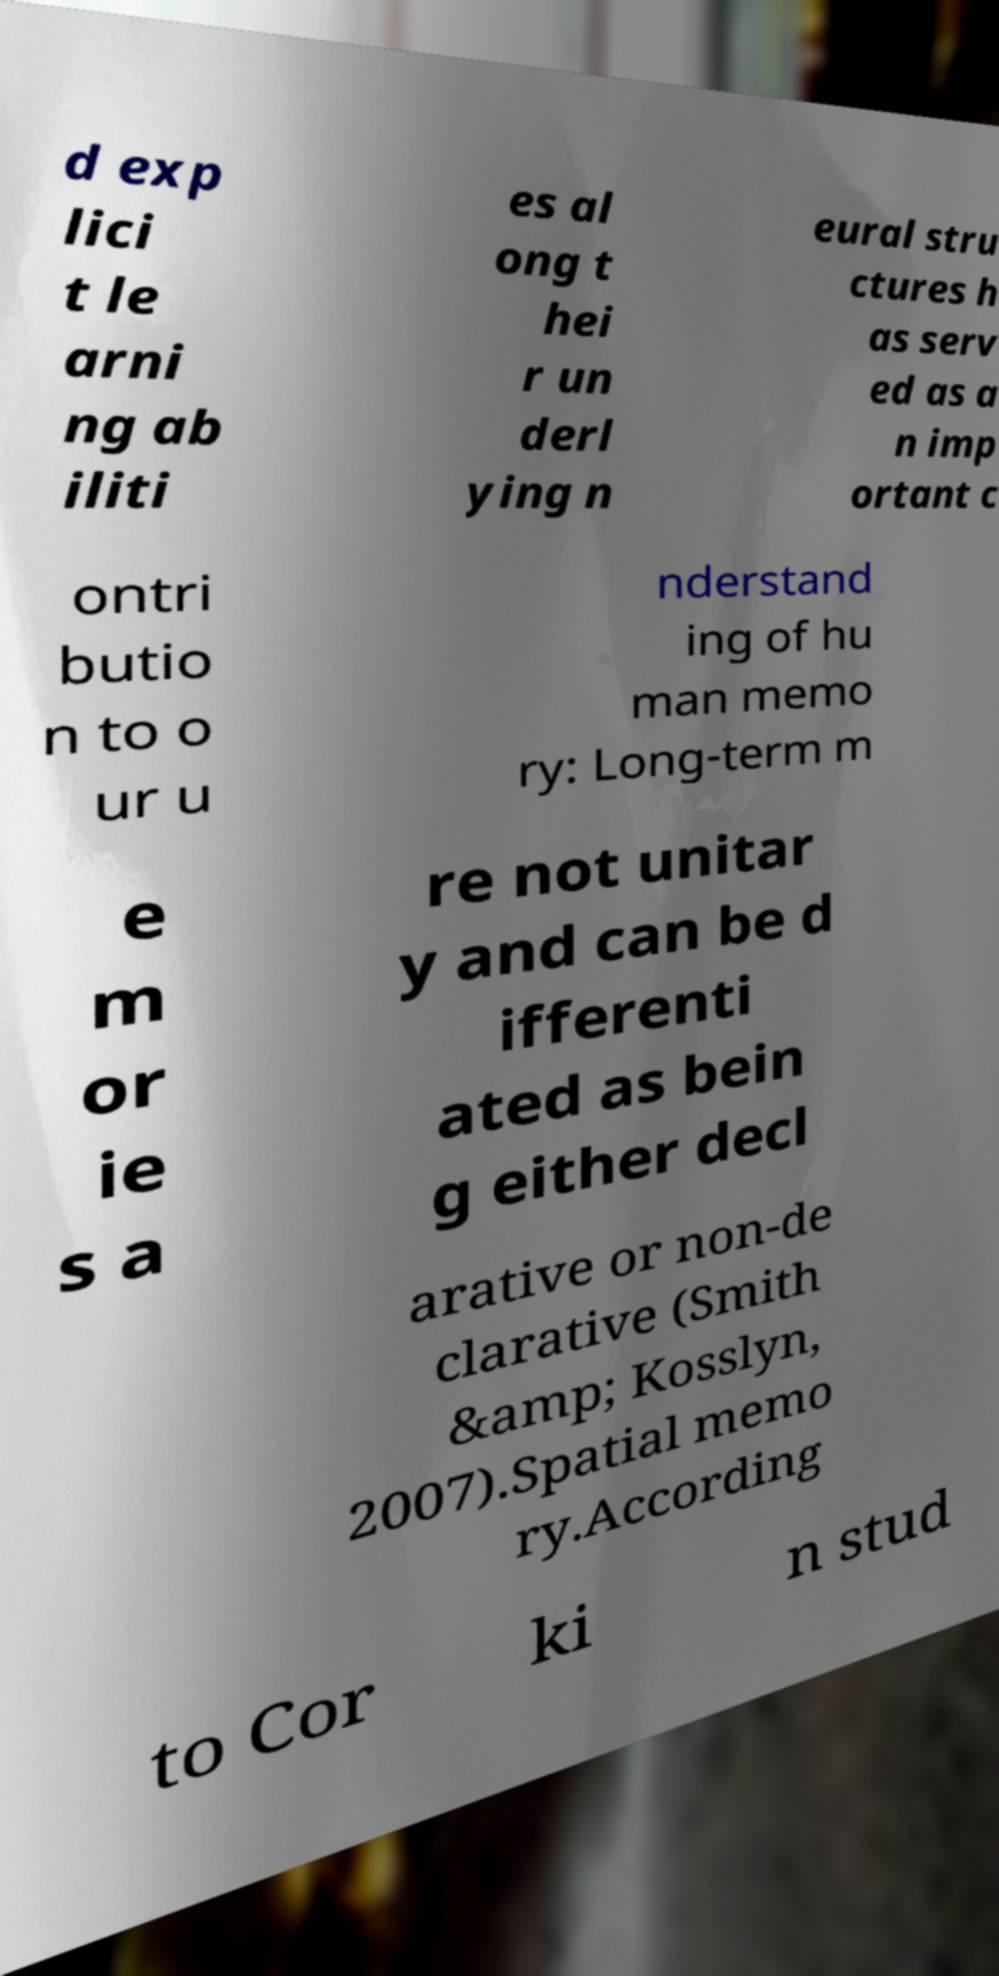For documentation purposes, I need the text within this image transcribed. Could you provide that? d exp lici t le arni ng ab iliti es al ong t hei r un derl ying n eural stru ctures h as serv ed as a n imp ortant c ontri butio n to o ur u nderstand ing of hu man memo ry: Long-term m e m or ie s a re not unitar y and can be d ifferenti ated as bein g either decl arative or non-de clarative (Smith &amp; Kosslyn, 2007).Spatial memo ry.According to Cor ki n stud 